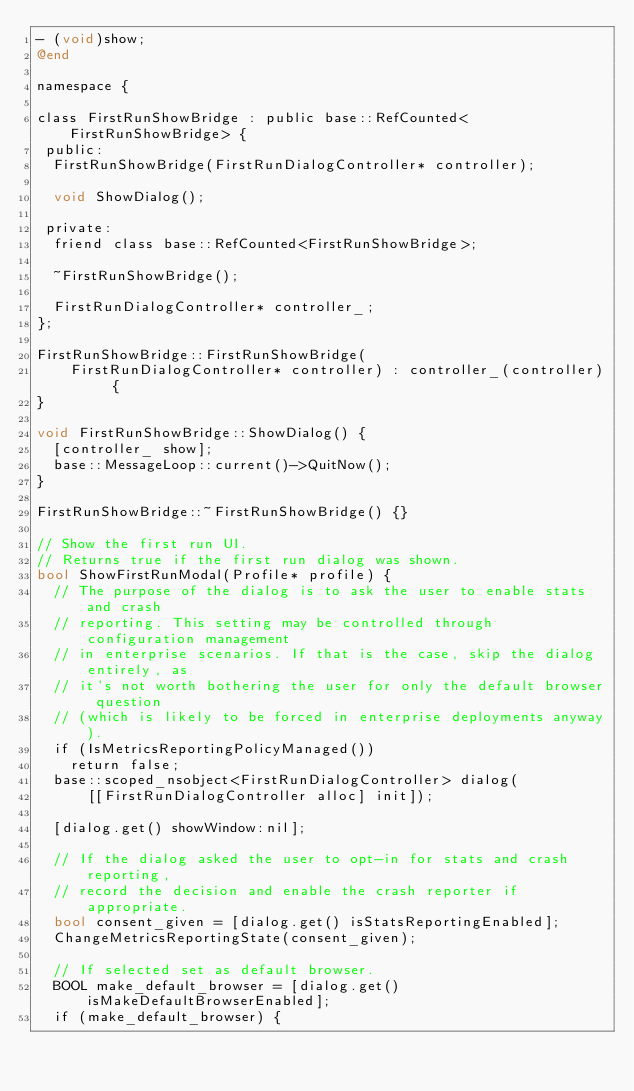<code> <loc_0><loc_0><loc_500><loc_500><_ObjectiveC_>- (void)show;
@end

namespace {

class FirstRunShowBridge : public base::RefCounted<FirstRunShowBridge> {
 public:
  FirstRunShowBridge(FirstRunDialogController* controller);

  void ShowDialog();

 private:
  friend class base::RefCounted<FirstRunShowBridge>;

  ~FirstRunShowBridge();

  FirstRunDialogController* controller_;
};

FirstRunShowBridge::FirstRunShowBridge(
    FirstRunDialogController* controller) : controller_(controller) {
}

void FirstRunShowBridge::ShowDialog() {
  [controller_ show];
  base::MessageLoop::current()->QuitNow();
}

FirstRunShowBridge::~FirstRunShowBridge() {}

// Show the first run UI.
// Returns true if the first run dialog was shown.
bool ShowFirstRunModal(Profile* profile) {
  // The purpose of the dialog is to ask the user to enable stats and crash
  // reporting. This setting may be controlled through configuration management
  // in enterprise scenarios. If that is the case, skip the dialog entirely, as
  // it's not worth bothering the user for only the default browser question
  // (which is likely to be forced in enterprise deployments anyway).
  if (IsMetricsReportingPolicyManaged())
    return false;
  base::scoped_nsobject<FirstRunDialogController> dialog(
      [[FirstRunDialogController alloc] init]);

  [dialog.get() showWindow:nil];

  // If the dialog asked the user to opt-in for stats and crash reporting,
  // record the decision and enable the crash reporter if appropriate.
  bool consent_given = [dialog.get() isStatsReportingEnabled];
  ChangeMetricsReportingState(consent_given);

  // If selected set as default browser.
  BOOL make_default_browser = [dialog.get() isMakeDefaultBrowserEnabled];
  if (make_default_browser) {</code> 